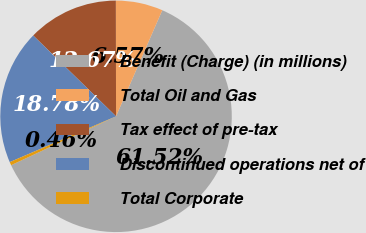Convert chart. <chart><loc_0><loc_0><loc_500><loc_500><pie_chart><fcel>Benefit (Charge) (in millions)<fcel>Total Oil and Gas<fcel>Tax effect of pre-tax<fcel>Discontinued operations net of<fcel>Total Corporate<nl><fcel>61.52%<fcel>6.57%<fcel>12.67%<fcel>18.78%<fcel>0.46%<nl></chart> 